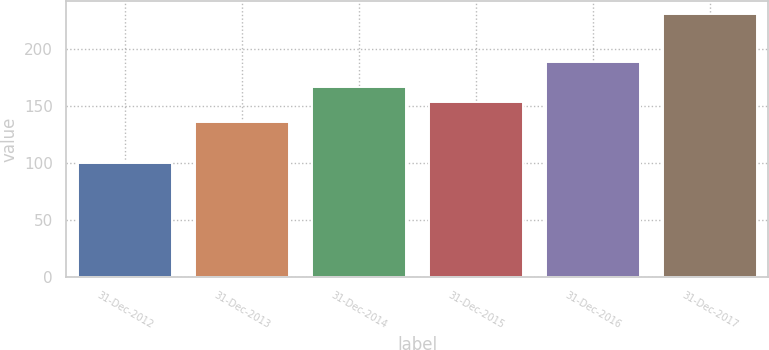Convert chart to OTSL. <chart><loc_0><loc_0><loc_500><loc_500><bar_chart><fcel>31-Dec-2012<fcel>31-Dec-2013<fcel>31-Dec-2014<fcel>31-Dec-2015<fcel>31-Dec-2016<fcel>31-Dec-2017<nl><fcel>100<fcel>135.6<fcel>166.99<fcel>153.9<fcel>188.9<fcel>230.9<nl></chart> 